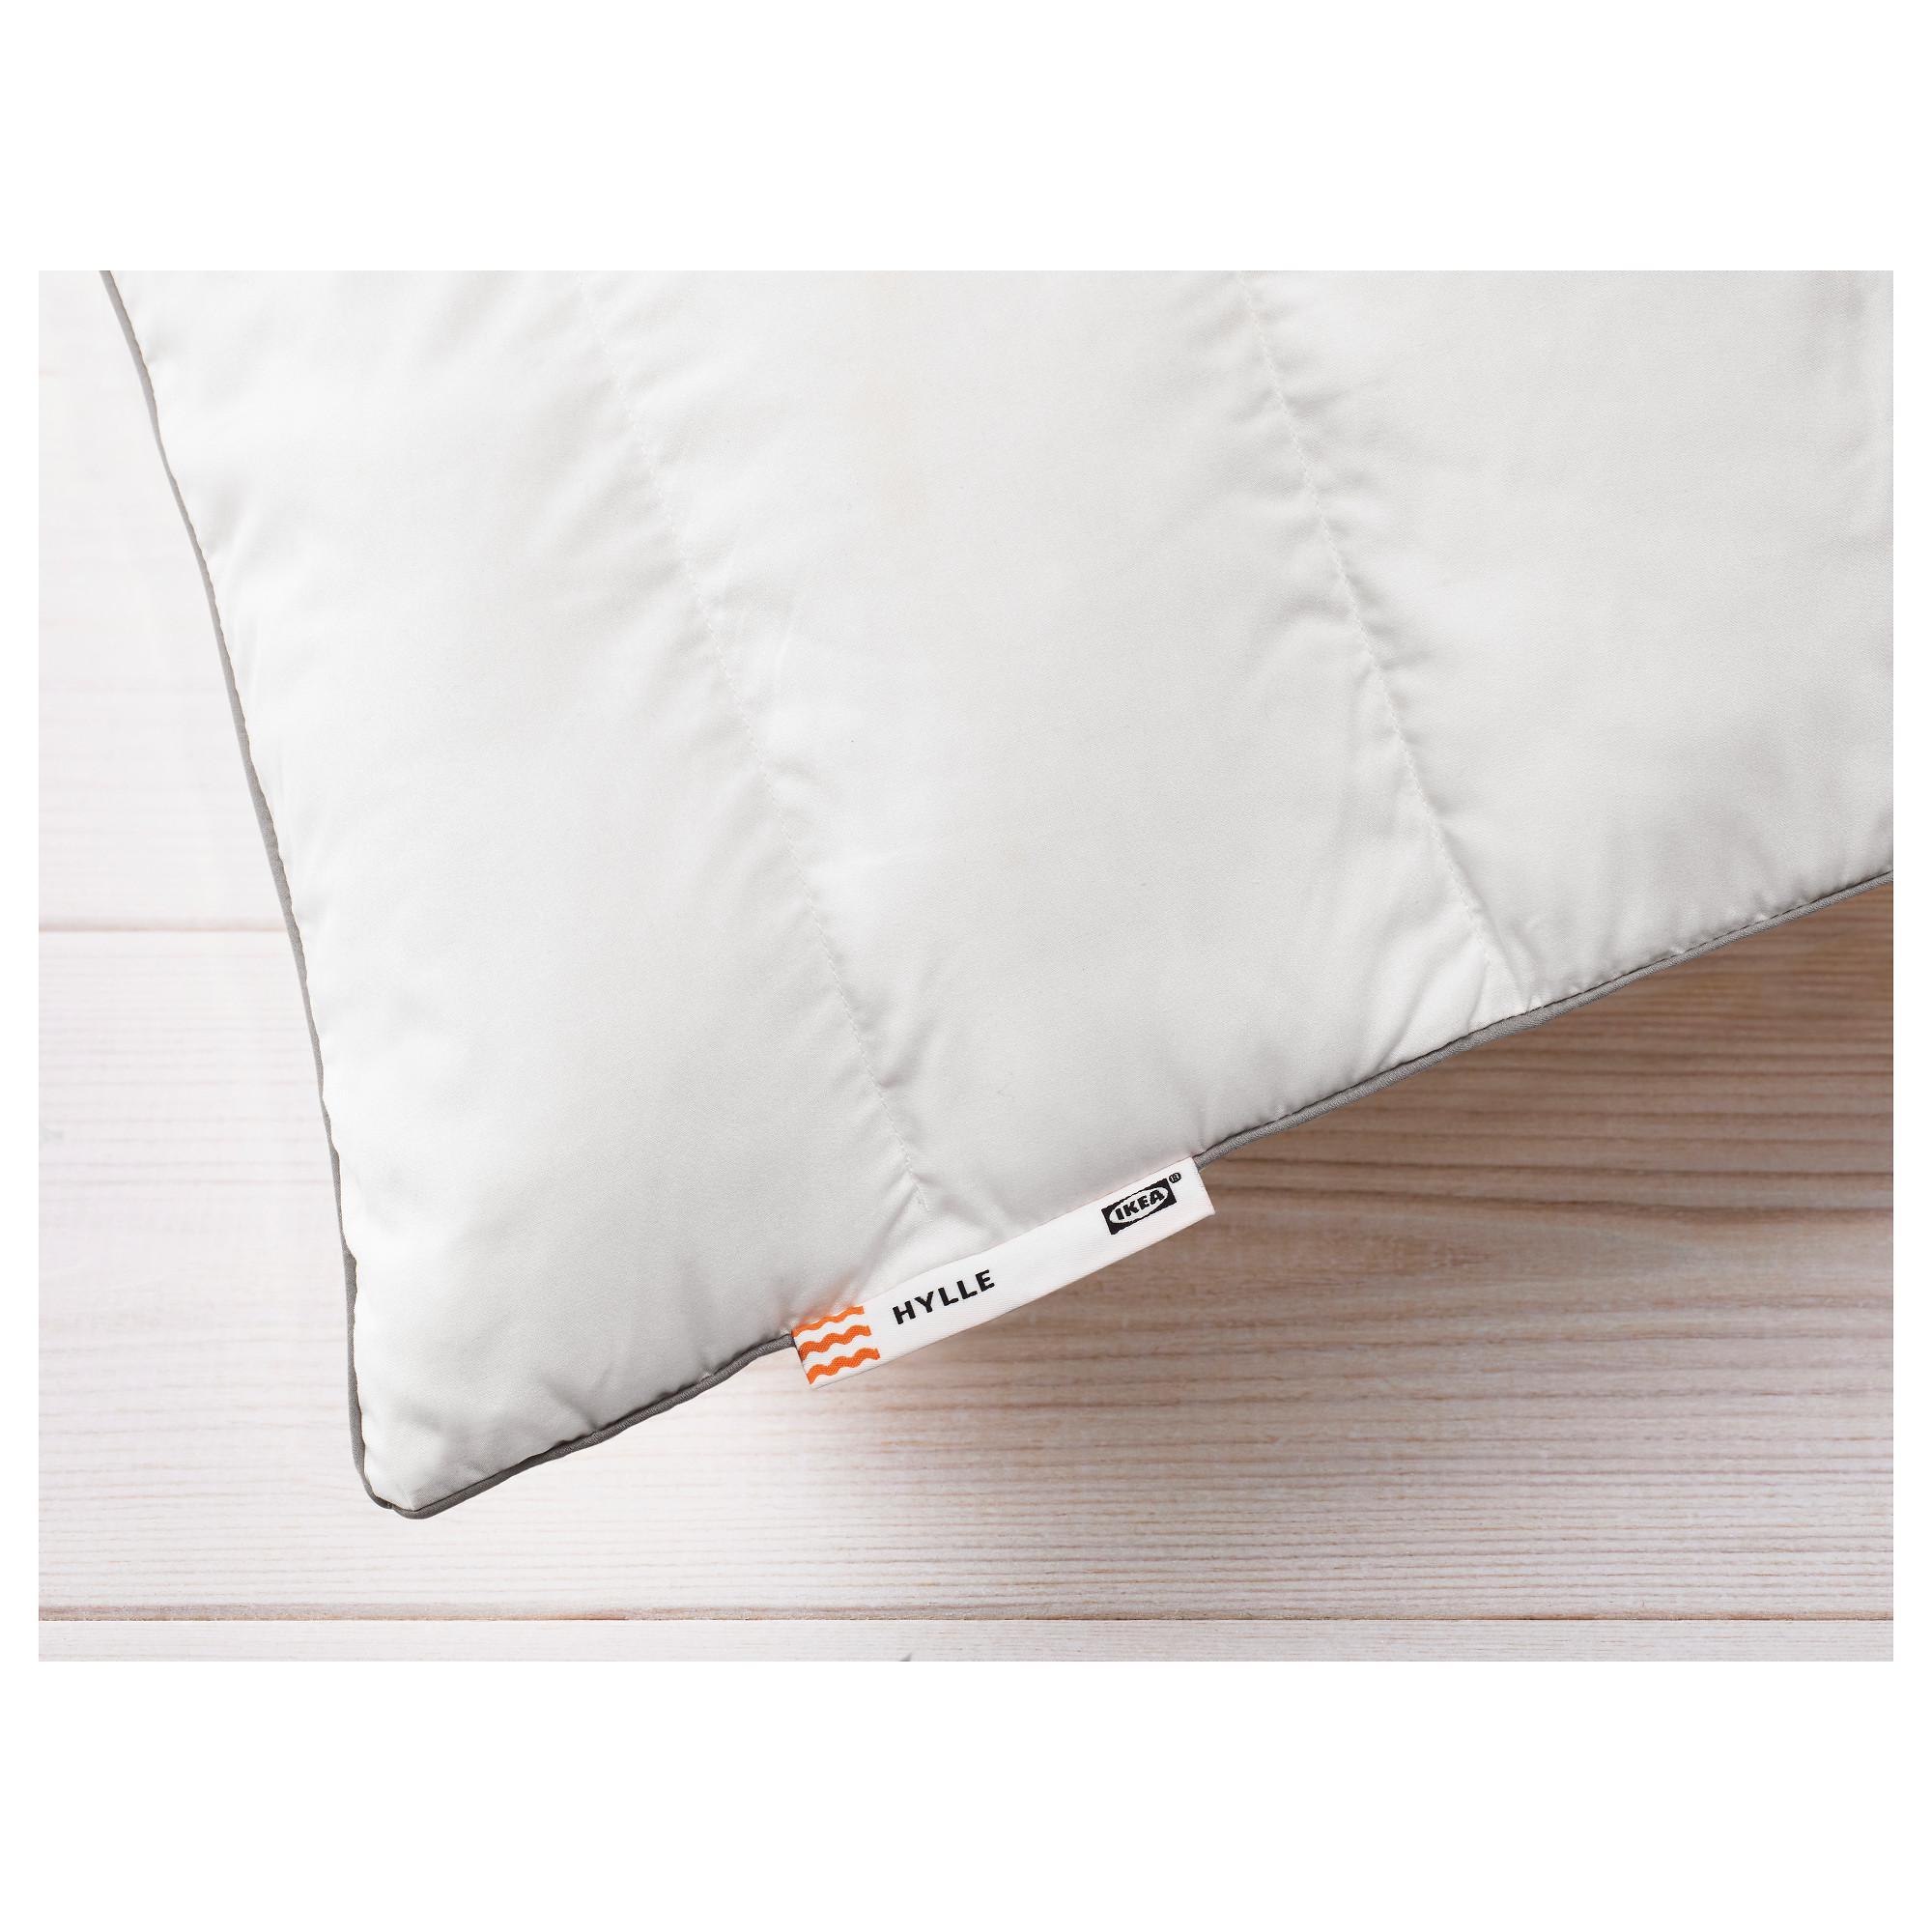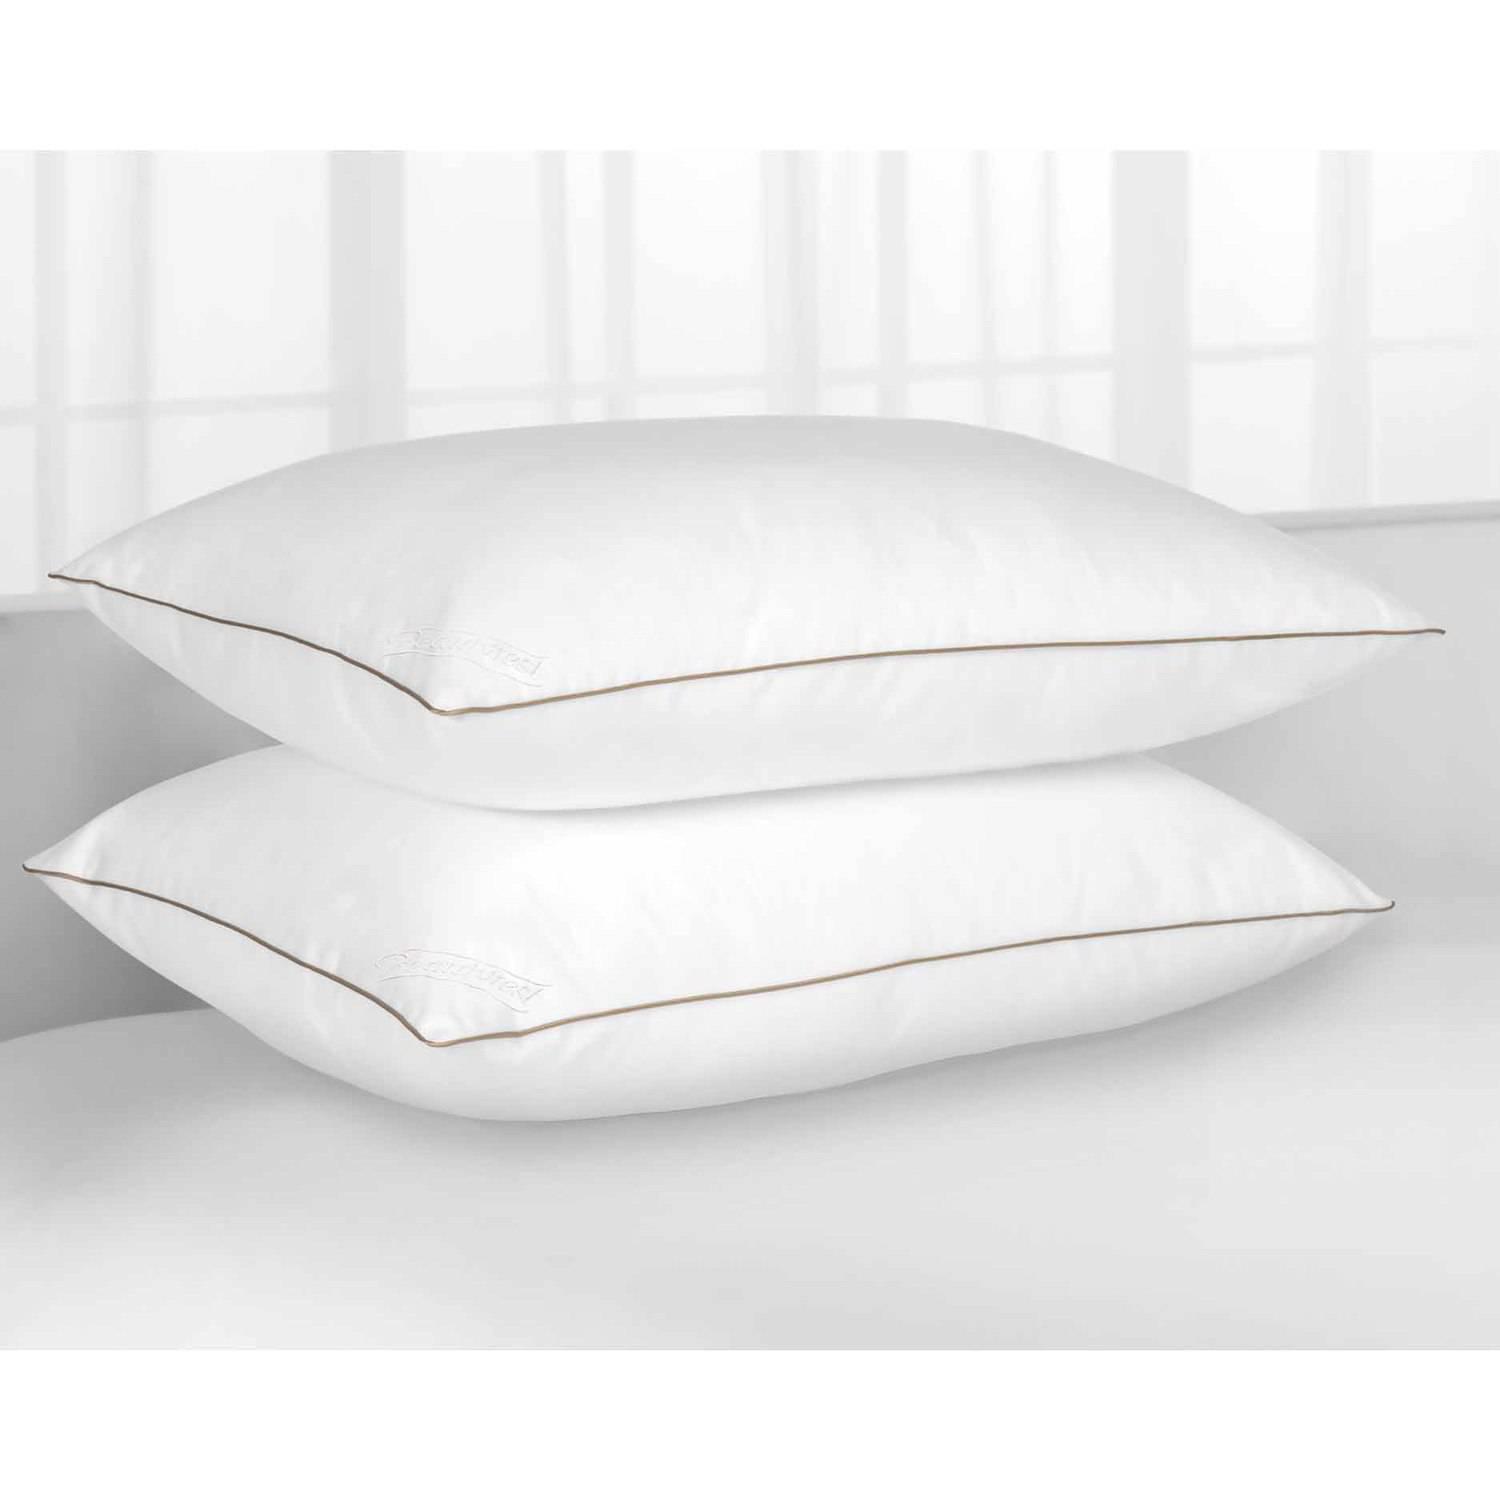The first image is the image on the left, the second image is the image on the right. Considering the images on both sides, is "An image includes a sculpted pillow with a depression for the sleeper's neck." valid? Answer yes or no. No. The first image is the image on the left, the second image is the image on the right. Considering the images on both sides, is "Two pillows are leaning against each other in the image on the right." valid? Answer yes or no. No. 